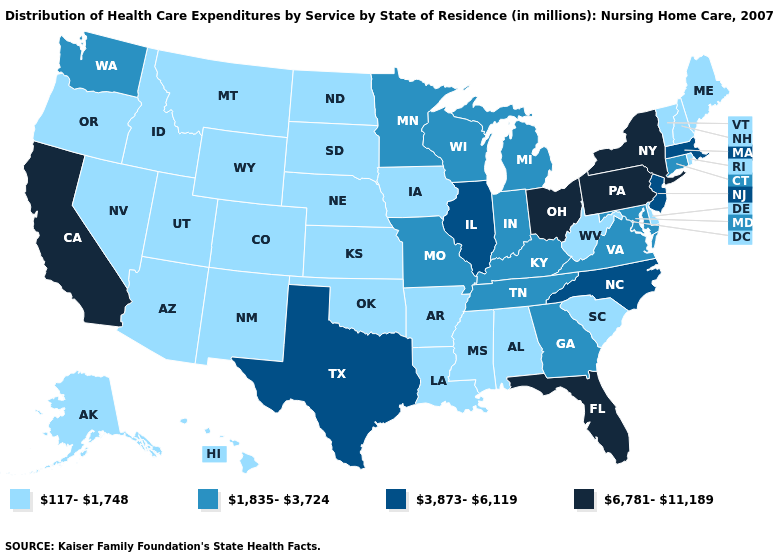Name the states that have a value in the range 1,835-3,724?
Short answer required. Connecticut, Georgia, Indiana, Kentucky, Maryland, Michigan, Minnesota, Missouri, Tennessee, Virginia, Washington, Wisconsin. What is the value of Florida?
Quick response, please. 6,781-11,189. What is the lowest value in states that border Connecticut?
Concise answer only. 117-1,748. Which states have the highest value in the USA?
Give a very brief answer. California, Florida, New York, Ohio, Pennsylvania. Among the states that border Michigan , which have the lowest value?
Answer briefly. Indiana, Wisconsin. Does Iowa have a lower value than Kansas?
Short answer required. No. Name the states that have a value in the range 6,781-11,189?
Concise answer only. California, Florida, New York, Ohio, Pennsylvania. Among the states that border Idaho , does Utah have the highest value?
Write a very short answer. No. Name the states that have a value in the range 1,835-3,724?
Concise answer only. Connecticut, Georgia, Indiana, Kentucky, Maryland, Michigan, Minnesota, Missouri, Tennessee, Virginia, Washington, Wisconsin. Name the states that have a value in the range 1,835-3,724?
Short answer required. Connecticut, Georgia, Indiana, Kentucky, Maryland, Michigan, Minnesota, Missouri, Tennessee, Virginia, Washington, Wisconsin. Name the states that have a value in the range 1,835-3,724?
Short answer required. Connecticut, Georgia, Indiana, Kentucky, Maryland, Michigan, Minnesota, Missouri, Tennessee, Virginia, Washington, Wisconsin. What is the value of Montana?
Concise answer only. 117-1,748. Name the states that have a value in the range 117-1,748?
Concise answer only. Alabama, Alaska, Arizona, Arkansas, Colorado, Delaware, Hawaii, Idaho, Iowa, Kansas, Louisiana, Maine, Mississippi, Montana, Nebraska, Nevada, New Hampshire, New Mexico, North Dakota, Oklahoma, Oregon, Rhode Island, South Carolina, South Dakota, Utah, Vermont, West Virginia, Wyoming. Among the states that border Iowa , does Minnesota have the highest value?
Write a very short answer. No. 